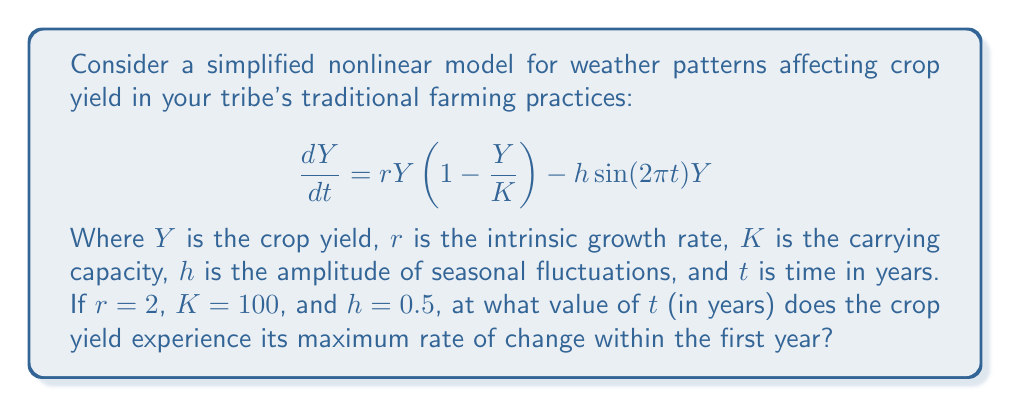Teach me how to tackle this problem. To find the maximum rate of change, we need to follow these steps:

1) First, let's expand the given equation:
   $$\frac{dY}{dt} = 2Y(1-\frac{Y}{100}) - 0.5\sin(2\pi t)Y$$

2) To find the maximum rate of change, we need to find the maximum value of $\frac{dY}{dt}$. This occurs when $\sin(2\pi t)$ is at its minimum (-1), as this term is subtracted.

3) The sine function reaches its minimum when its argument is $\frac{3\pi}{2}$. So we need to solve:
   $$2\pi t = \frac{3\pi}{2}$$

4) Solving for $t$:
   $$t = \frac{3}{4} = 0.75$$

5) This means the maximum rate of change occurs at $t = 0.75$ years, or 9 months into the year.

6) This aligns with traditional agricultural knowledge, as many crops reach their peak growth rate towards the end of the growing season, often around harvest time.
Answer: 0.75 years 